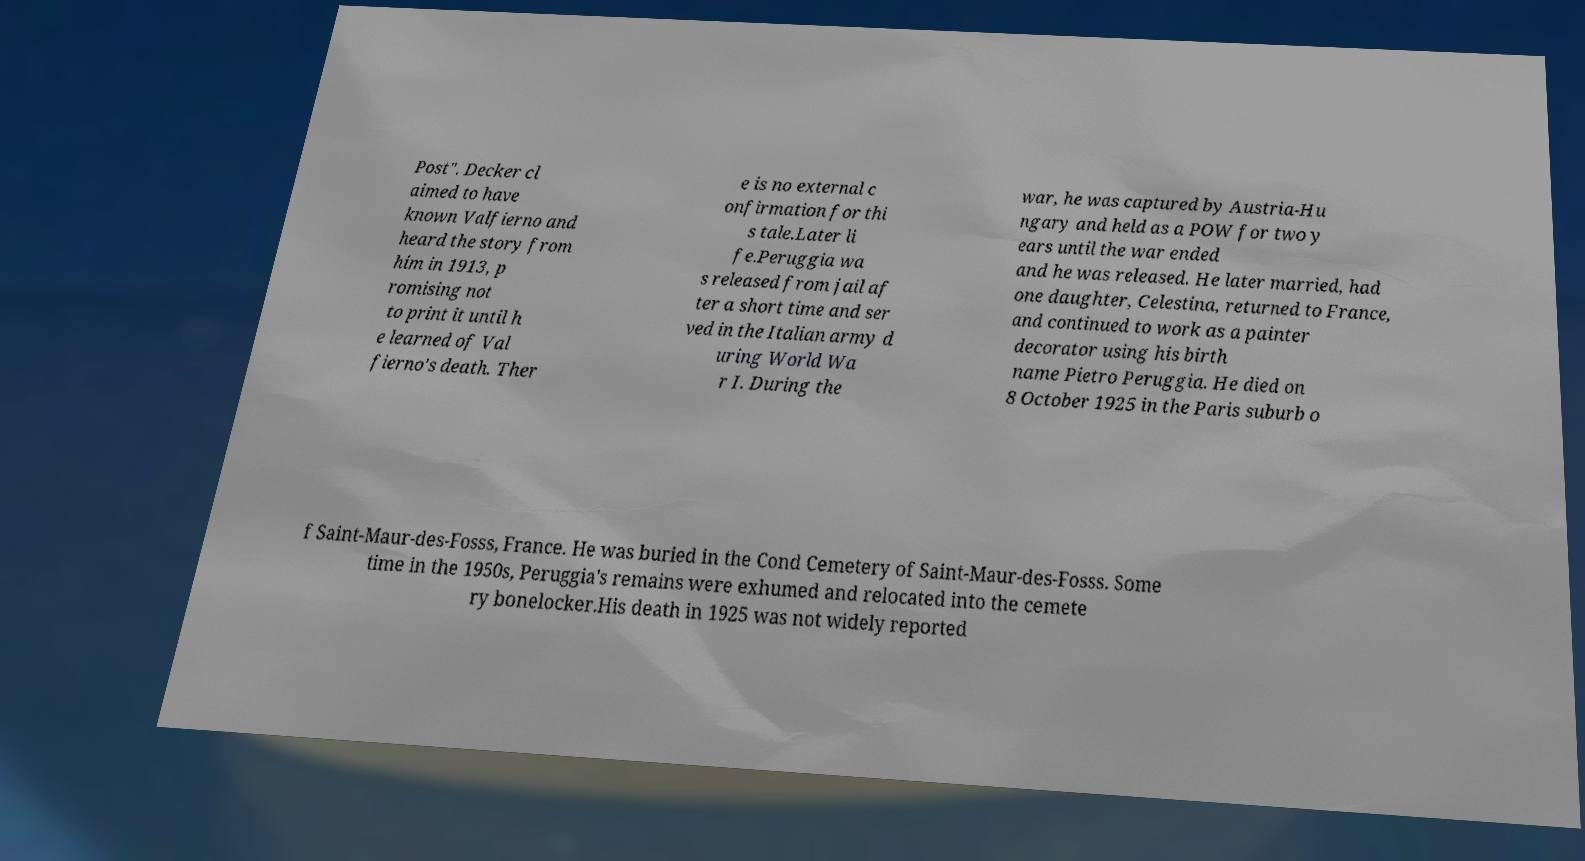Please read and relay the text visible in this image. What does it say? Post". Decker cl aimed to have known Valfierno and heard the story from him in 1913, p romising not to print it until h e learned of Val fierno's death. Ther e is no external c onfirmation for thi s tale.Later li fe.Peruggia wa s released from jail af ter a short time and ser ved in the Italian army d uring World Wa r I. During the war, he was captured by Austria-Hu ngary and held as a POW for two y ears until the war ended and he was released. He later married, had one daughter, Celestina, returned to France, and continued to work as a painter decorator using his birth name Pietro Peruggia. He died on 8 October 1925 in the Paris suburb o f Saint-Maur-des-Fosss, France. He was buried in the Cond Cemetery of Saint-Maur-des-Fosss. Some time in the 1950s, Peruggia's remains were exhumed and relocated into the cemete ry bonelocker.His death in 1925 was not widely reported 